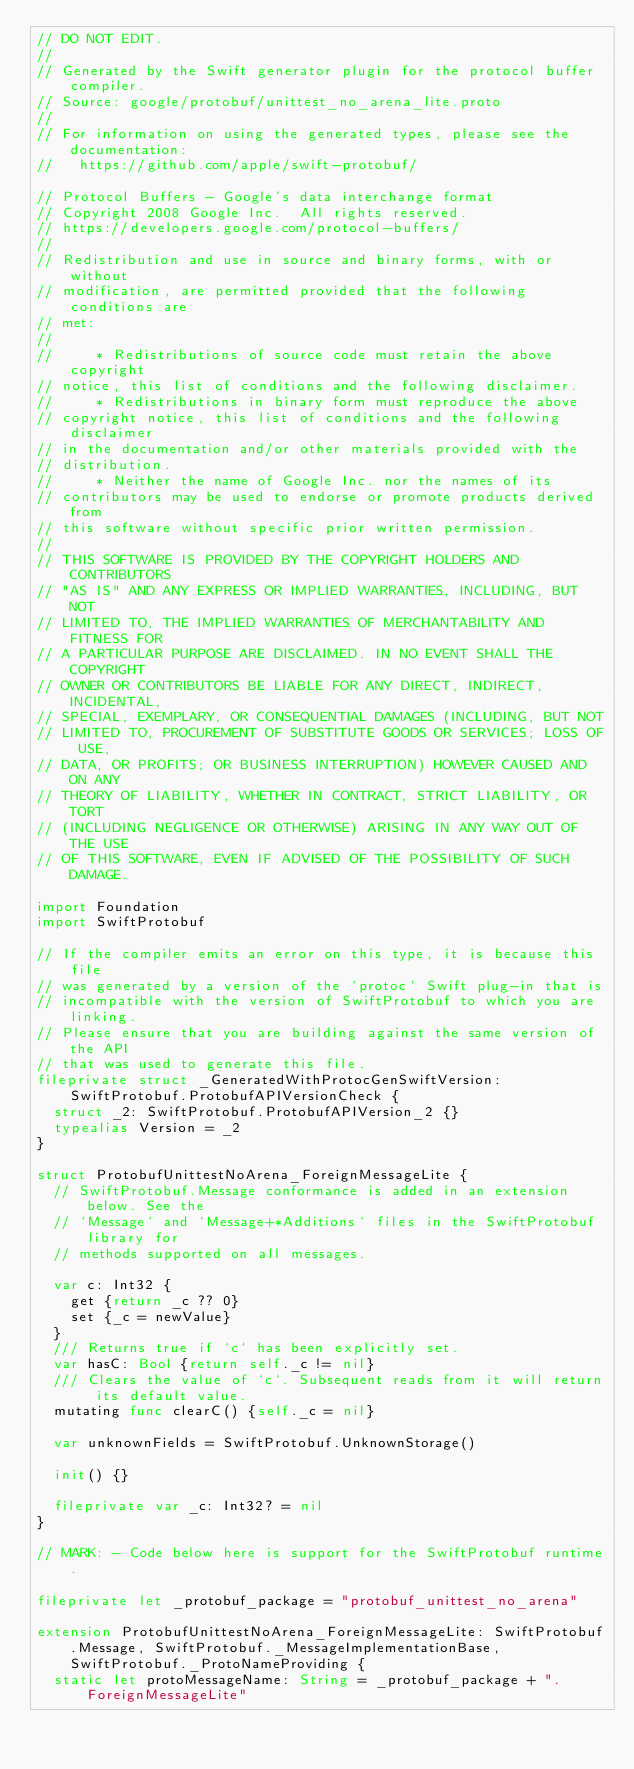<code> <loc_0><loc_0><loc_500><loc_500><_Swift_>// DO NOT EDIT.
//
// Generated by the Swift generator plugin for the protocol buffer compiler.
// Source: google/protobuf/unittest_no_arena_lite.proto
//
// For information on using the generated types, please see the documentation:
//   https://github.com/apple/swift-protobuf/

// Protocol Buffers - Google's data interchange format
// Copyright 2008 Google Inc.  All rights reserved.
// https://developers.google.com/protocol-buffers/
//
// Redistribution and use in source and binary forms, with or without
// modification, are permitted provided that the following conditions are
// met:
//
//     * Redistributions of source code must retain the above copyright
// notice, this list of conditions and the following disclaimer.
//     * Redistributions in binary form must reproduce the above
// copyright notice, this list of conditions and the following disclaimer
// in the documentation and/or other materials provided with the
// distribution.
//     * Neither the name of Google Inc. nor the names of its
// contributors may be used to endorse or promote products derived from
// this software without specific prior written permission.
//
// THIS SOFTWARE IS PROVIDED BY THE COPYRIGHT HOLDERS AND CONTRIBUTORS
// "AS IS" AND ANY EXPRESS OR IMPLIED WARRANTIES, INCLUDING, BUT NOT
// LIMITED TO, THE IMPLIED WARRANTIES OF MERCHANTABILITY AND FITNESS FOR
// A PARTICULAR PURPOSE ARE DISCLAIMED. IN NO EVENT SHALL THE COPYRIGHT
// OWNER OR CONTRIBUTORS BE LIABLE FOR ANY DIRECT, INDIRECT, INCIDENTAL,
// SPECIAL, EXEMPLARY, OR CONSEQUENTIAL DAMAGES (INCLUDING, BUT NOT
// LIMITED TO, PROCUREMENT OF SUBSTITUTE GOODS OR SERVICES; LOSS OF USE,
// DATA, OR PROFITS; OR BUSINESS INTERRUPTION) HOWEVER CAUSED AND ON ANY
// THEORY OF LIABILITY, WHETHER IN CONTRACT, STRICT LIABILITY, OR TORT
// (INCLUDING NEGLIGENCE OR OTHERWISE) ARISING IN ANY WAY OUT OF THE USE
// OF THIS SOFTWARE, EVEN IF ADVISED OF THE POSSIBILITY OF SUCH DAMAGE.

import Foundation
import SwiftProtobuf

// If the compiler emits an error on this type, it is because this file
// was generated by a version of the `protoc` Swift plug-in that is
// incompatible with the version of SwiftProtobuf to which you are linking.
// Please ensure that you are building against the same version of the API
// that was used to generate this file.
fileprivate struct _GeneratedWithProtocGenSwiftVersion: SwiftProtobuf.ProtobufAPIVersionCheck {
  struct _2: SwiftProtobuf.ProtobufAPIVersion_2 {}
  typealias Version = _2
}

struct ProtobufUnittestNoArena_ForeignMessageLite {
  // SwiftProtobuf.Message conformance is added in an extension below. See the
  // `Message` and `Message+*Additions` files in the SwiftProtobuf library for
  // methods supported on all messages.

  var c: Int32 {
    get {return _c ?? 0}
    set {_c = newValue}
  }
  /// Returns true if `c` has been explicitly set.
  var hasC: Bool {return self._c != nil}
  /// Clears the value of `c`. Subsequent reads from it will return its default value.
  mutating func clearC() {self._c = nil}

  var unknownFields = SwiftProtobuf.UnknownStorage()

  init() {}

  fileprivate var _c: Int32? = nil
}

// MARK: - Code below here is support for the SwiftProtobuf runtime.

fileprivate let _protobuf_package = "protobuf_unittest_no_arena"

extension ProtobufUnittestNoArena_ForeignMessageLite: SwiftProtobuf.Message, SwiftProtobuf._MessageImplementationBase, SwiftProtobuf._ProtoNameProviding {
  static let protoMessageName: String = _protobuf_package + ".ForeignMessageLite"</code> 